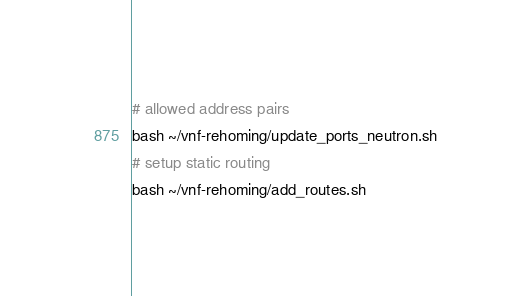Convert code to text. <code><loc_0><loc_0><loc_500><loc_500><_Bash_># allowed address pairs
bash ~/vnf-rehoming/update_ports_neutron.sh
# setup static routing
bash ~/vnf-rehoming/add_routes.sh
</code> 